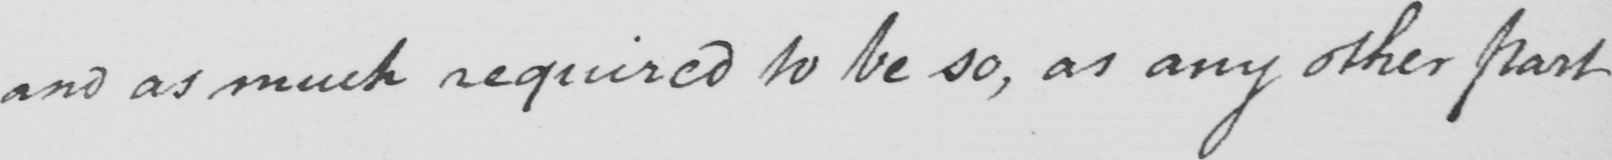Can you tell me what this handwritten text says? and as much required to be so , as any other part 